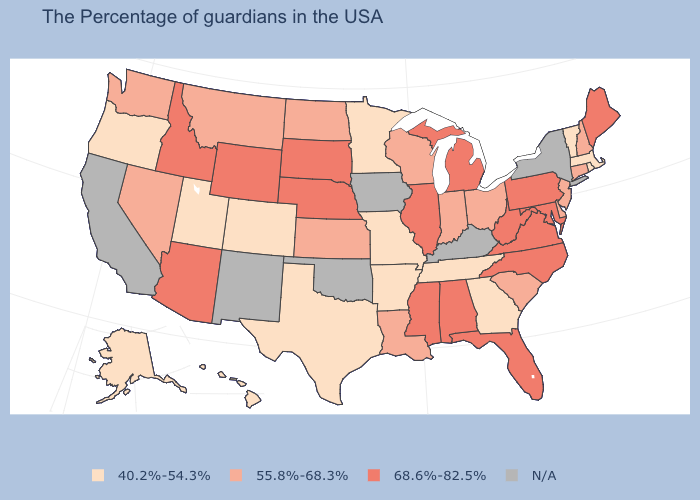Which states have the highest value in the USA?
Keep it brief. Maine, Maryland, Pennsylvania, Virginia, North Carolina, West Virginia, Florida, Michigan, Alabama, Illinois, Mississippi, Nebraska, South Dakota, Wyoming, Arizona, Idaho. What is the value of Georgia?
Write a very short answer. 40.2%-54.3%. Which states hav the highest value in the West?
Answer briefly. Wyoming, Arizona, Idaho. What is the value of Maine?
Answer briefly. 68.6%-82.5%. Name the states that have a value in the range 40.2%-54.3%?
Keep it brief. Massachusetts, Rhode Island, Vermont, Georgia, Tennessee, Missouri, Arkansas, Minnesota, Texas, Colorado, Utah, Oregon, Alaska, Hawaii. Name the states that have a value in the range 55.8%-68.3%?
Answer briefly. New Hampshire, Connecticut, New Jersey, Delaware, South Carolina, Ohio, Indiana, Wisconsin, Louisiana, Kansas, North Dakota, Montana, Nevada, Washington. What is the highest value in the South ?
Give a very brief answer. 68.6%-82.5%. What is the value of North Carolina?
Quick response, please. 68.6%-82.5%. What is the value of West Virginia?
Write a very short answer. 68.6%-82.5%. Among the states that border Washington , which have the highest value?
Short answer required. Idaho. Which states have the lowest value in the USA?
Give a very brief answer. Massachusetts, Rhode Island, Vermont, Georgia, Tennessee, Missouri, Arkansas, Minnesota, Texas, Colorado, Utah, Oregon, Alaska, Hawaii. Is the legend a continuous bar?
Keep it brief. No. What is the value of Maryland?
Give a very brief answer. 68.6%-82.5%. Is the legend a continuous bar?
Short answer required. No. 